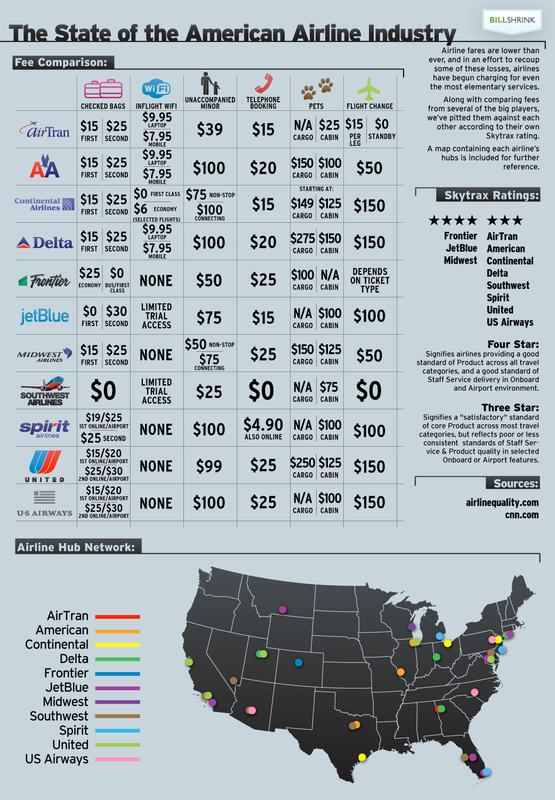Indicate a few pertinent items in this graphic. It is known that two airlines offer Limited Trial Access for inflight WiFi. It is known that Southwest airline has the lowest charge for unaccompanied minors. I have information that indicates that US Airways charges $100 for unaccompanied minor and $25 for telephone booking. Spirit charges $4.90 for telephone/online bookings. Southwest airline allows for free flight changes with no additional fees. 